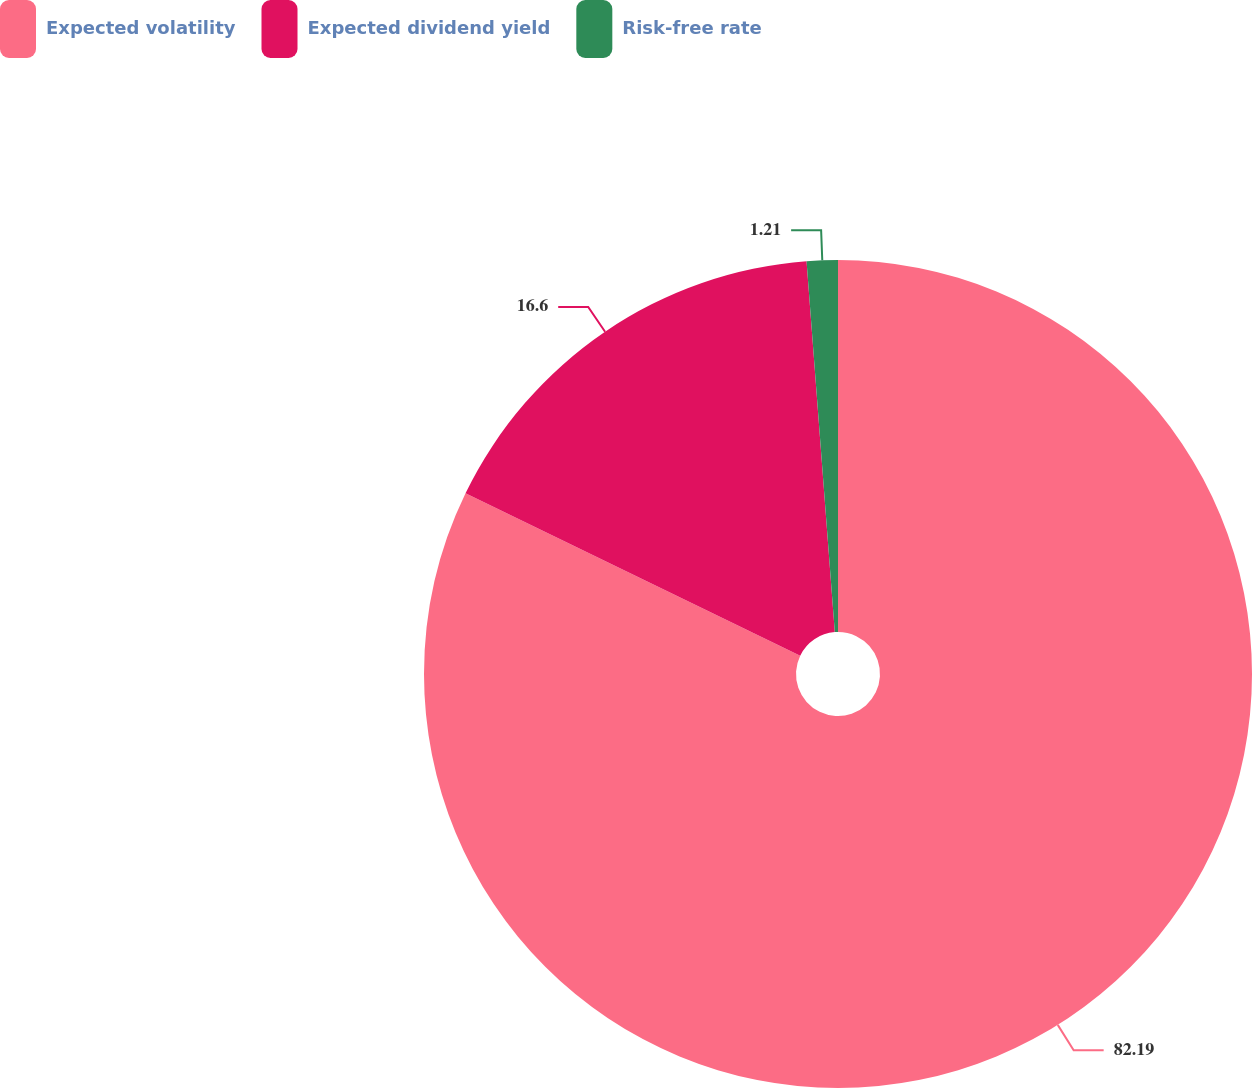Convert chart to OTSL. <chart><loc_0><loc_0><loc_500><loc_500><pie_chart><fcel>Expected volatility<fcel>Expected dividend yield<fcel>Risk-free rate<nl><fcel>82.19%<fcel>16.6%<fcel>1.21%<nl></chart> 